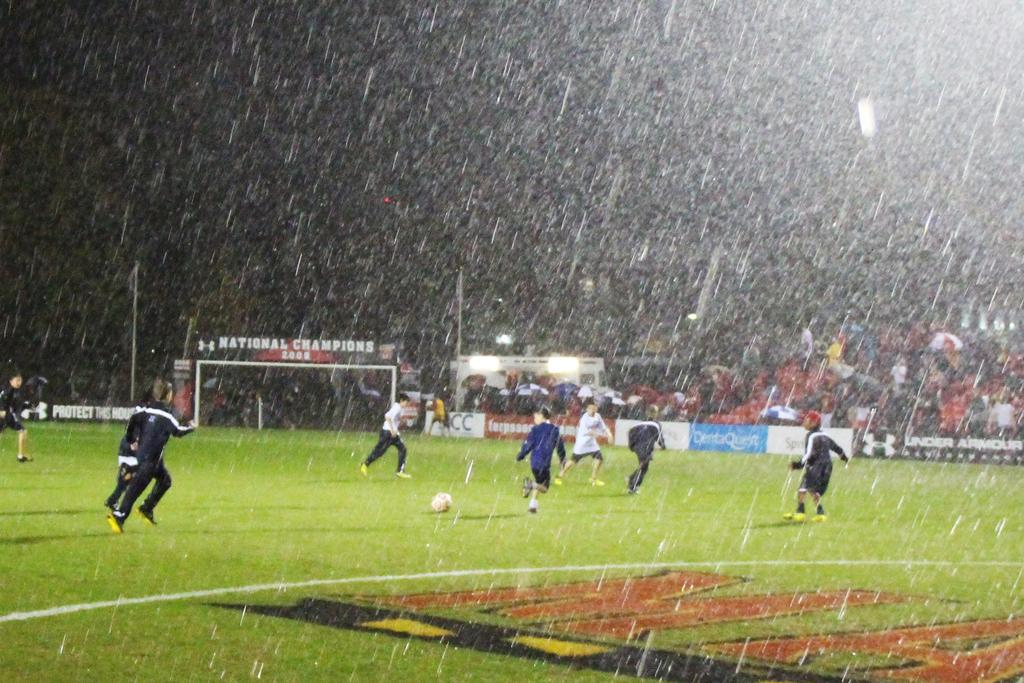<image>
Provide a brief description of the given image. People playing in the rain in a stadium with an sign that says national champions. 